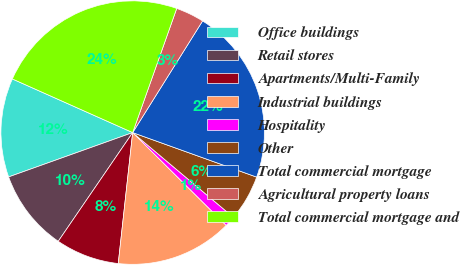<chart> <loc_0><loc_0><loc_500><loc_500><pie_chart><fcel>Office buildings<fcel>Retail stores<fcel>Apartments/Multi-Family<fcel>Industrial buildings<fcel>Hospitality<fcel>Other<fcel>Total commercial mortgage<fcel>Agricultural property loans<fcel>Total commercial mortgage and<nl><fcel>12.14%<fcel>9.98%<fcel>7.81%<fcel>14.31%<fcel>1.31%<fcel>5.64%<fcel>21.58%<fcel>3.48%<fcel>23.75%<nl></chart> 